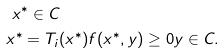<formula> <loc_0><loc_0><loc_500><loc_500>& \ x ^ { * } \in C \\ & x ^ { * } = T _ { i } ( x ^ { * } ) f ( x ^ { * } , y ) \geq 0 y \in C .</formula> 